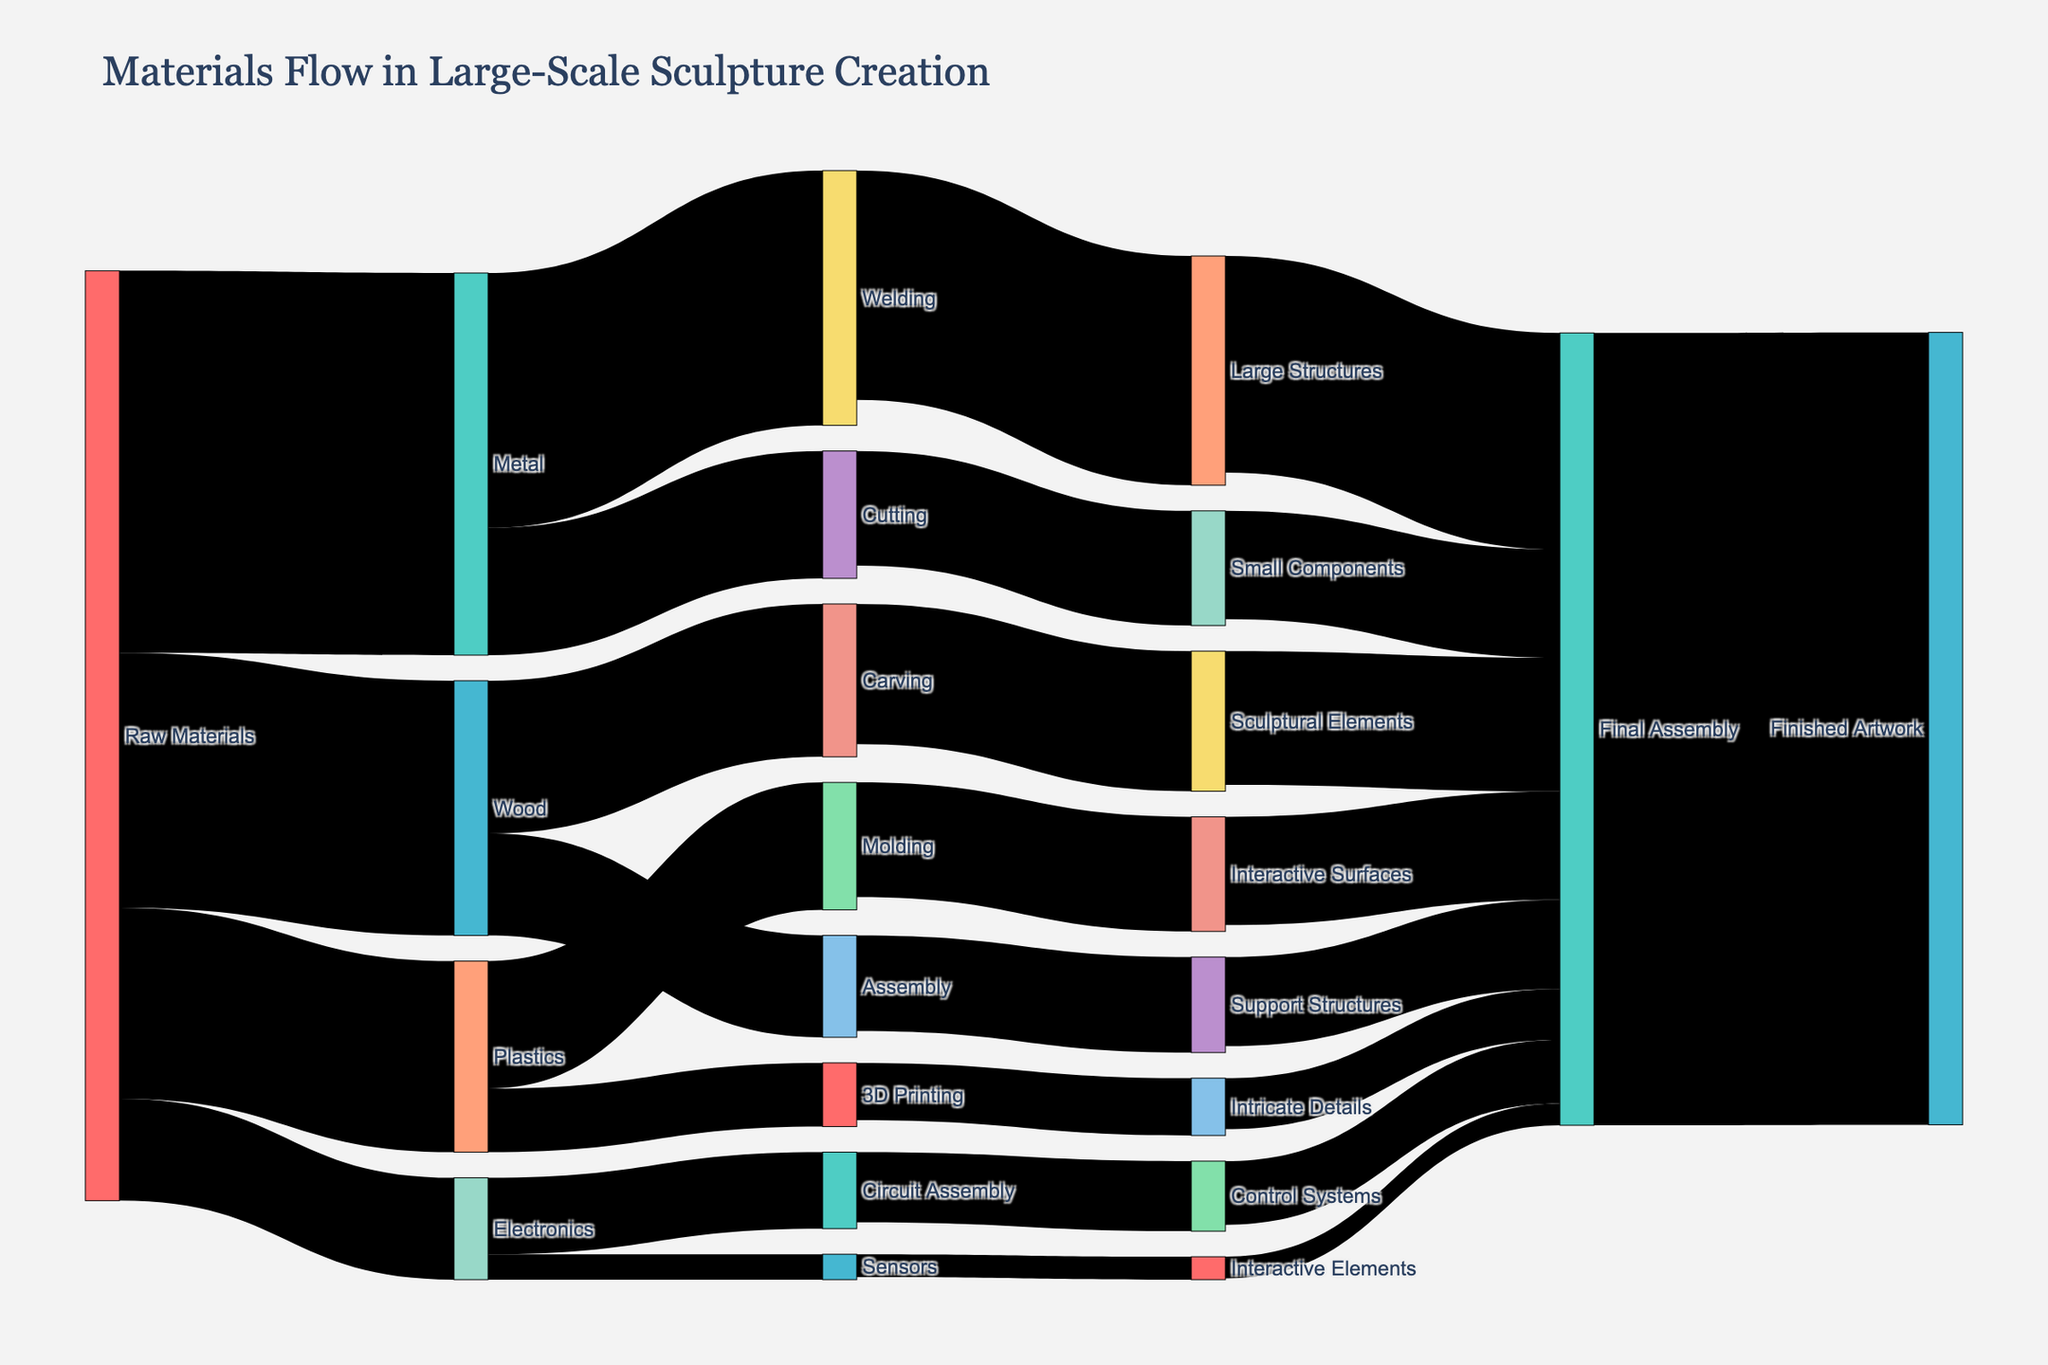How many different categories of raw materials are there? The figure shows different categories linked from "Raw Materials" to further steps. By counting these links, we can identify the number of categories.
Answer: 4 Which category receives the highest amount of raw materials? Referring to the values of materials flowing from "Raw Materials" to other categories (Metal: 3000, Wood: 2000, Plastics: 1500, Electronics: 800), we see that "Metal" has the highest value.
Answer: Metal What is the total value of materials used in Welding? To find the total value for Welding, we add up the values flowing into it. The diagram shows Metal -> Welding with a value of 2000.
Answer: 2000 How many distinct steps are involved before reaching the "Finished Artwork"? By tracing the flow, starting from raw materials to their derivatives and finally to "Finished Artwork," we identify four steps: Raw Materials -> Initial Processes -> Secondary Processes -> Final Assembly -> Finished Artwork.
Answer: 4 Which process contributes the least to the Final Assembly? By comparing the values of all flows into "Final Assembly," we look for the minimum value (Large Structures: 1700, Small Components: 850, Sculptural Elements: 1050, Support Structures: 700, Interactive Surfaces: 850, Intricate Details: 400, Control Systems: 500, Interactive Elements: 170). So, "Interactive Elements" has the lowest value.
Answer: Interactive Elements What is the combined value of materials used in Creating Interactive Surfaces and Integrating Sensors? We sum the values of Plastics -> Interactive Surfaces (900) and Electronics -> Sensors (200). The total is 900 + 200.
Answer: 1100 How does the amount of Metal used in Large Structures compare to that used in Small Components? Referring to the diagram, Metal -> Large Structures has a value of 1800, while Metal -> Small Components has a value of 900. So, Large Structures use twice the amount compared to Small Components.
Answer: Large Structures use twice the amount Which part of the process has the most complex flow of materials in terms of the number of contributing components? By examining components contributing to each final stage, Final Assembly receives inputs from multiple stages (Large Structures, Small Components, Sculptural Elements, etc.). Therefore, it has the most complex flow.
Answer: Final Assembly From the starting point of Raw Materials, which process directly receives the smallest amount of material? By comparing initial values directly from Raw Materials (Metal: 3000, Wood: 2000, Plastics: 1500, Electronics: 800), the smallest value flows to Electronics.
Answer: Electronics What is the value flow from Carving to Sculptural Elements? Referring to the diagram, the flow from Wood -> Carving -> Sculptural Elements shows a value of 1100 from Carving to Sculptural Elements.
Answer: 1100 